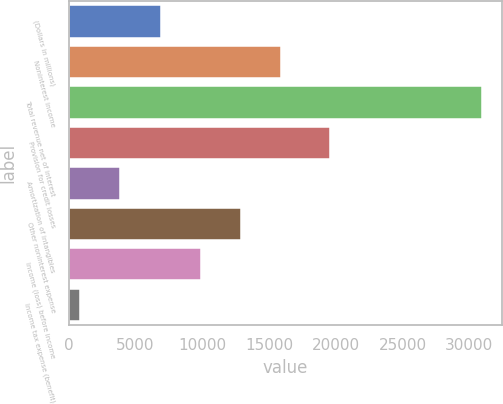Convert chart to OTSL. <chart><loc_0><loc_0><loc_500><loc_500><bar_chart><fcel>(Dollars in millions)<fcel>Noninterest income<fcel>Total revenue net of interest<fcel>Provision for credit losses<fcel>Amortization of intangibles<fcel>Other noninterest expense<fcel>Income (loss) before income<fcel>Income tax expense (benefit)<nl><fcel>6866.6<fcel>15891.5<fcel>30933<fcel>19575<fcel>3858.3<fcel>12883.2<fcel>9874.9<fcel>850<nl></chart> 